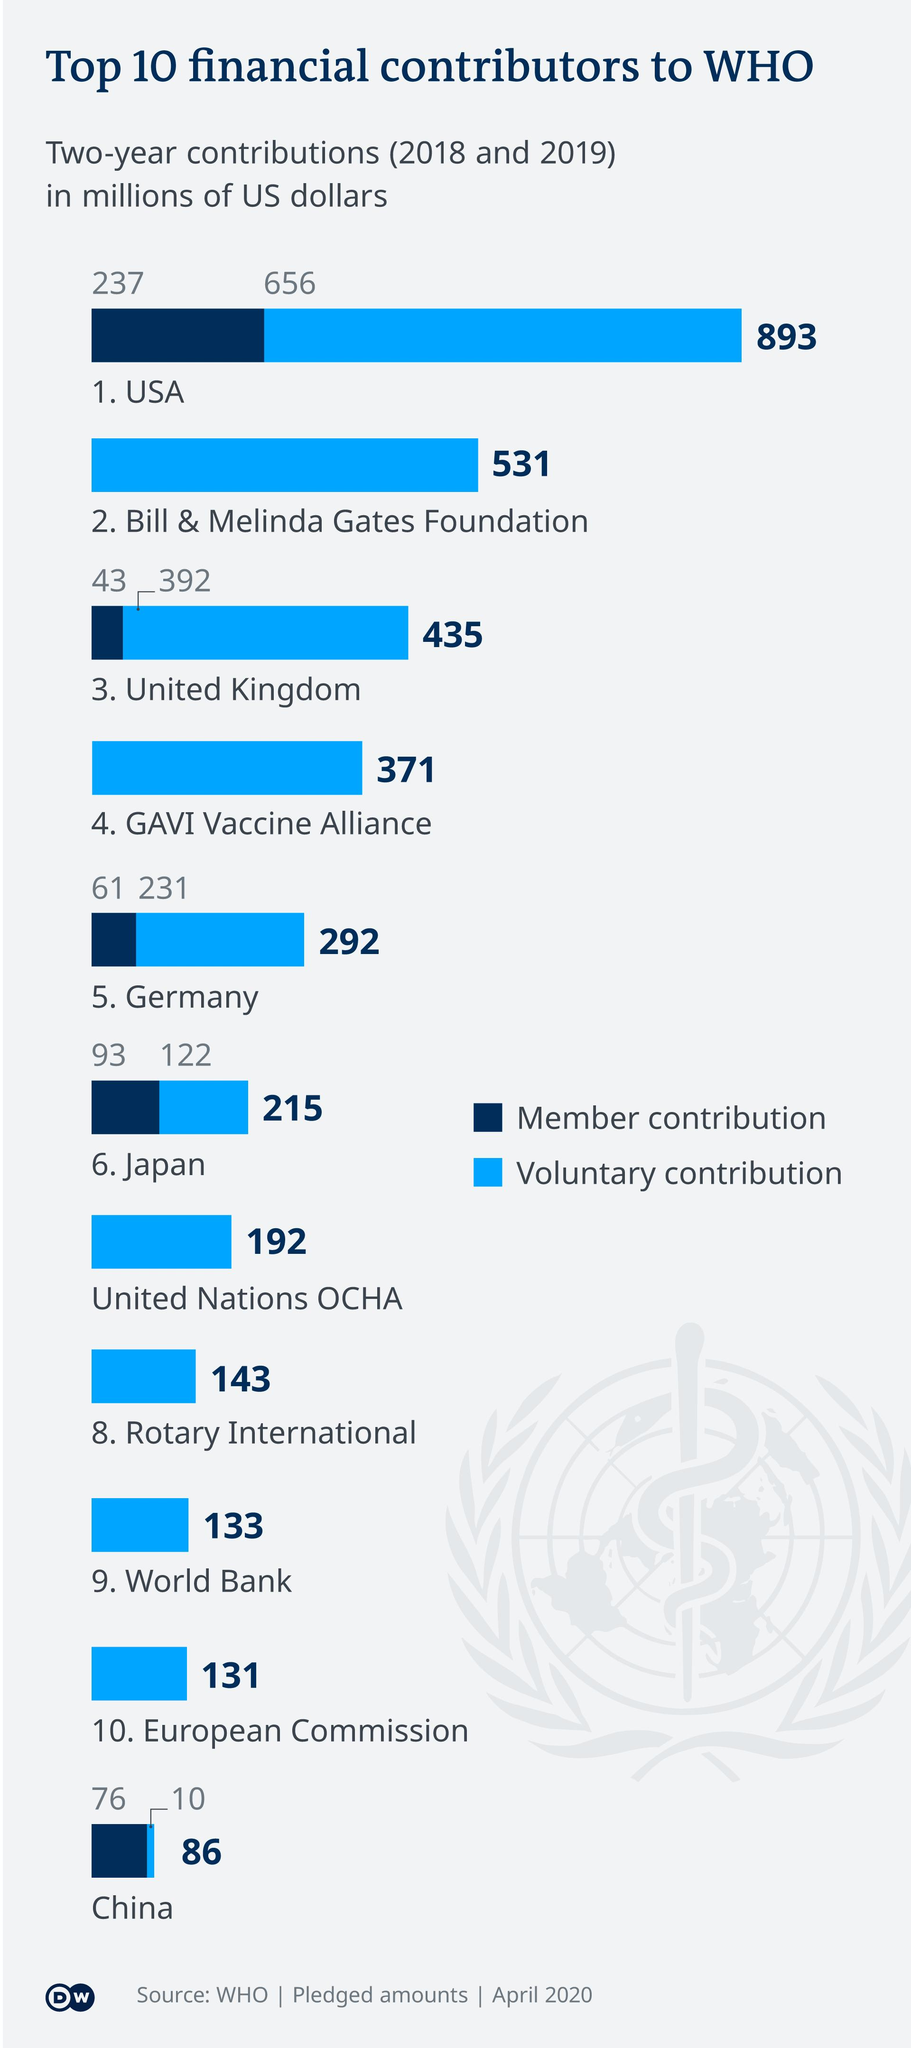Specify some key components in this picture. Three of the major financial contributors to the World Health Organization (WHO) are the United States of America, the Bill & Melinda Gates Foundation, and the United Kingdom. The voluntary contribution made by China was approximately $10 million. Japan's contribution to the World Health Organization (WHO) is $215 million. In 2021, China's contribution to the World Health Organization (WHO) was approximately $86 million. The contribution of Rotary International is higher than that of the World Bank by a significant amount, around $10 million. 